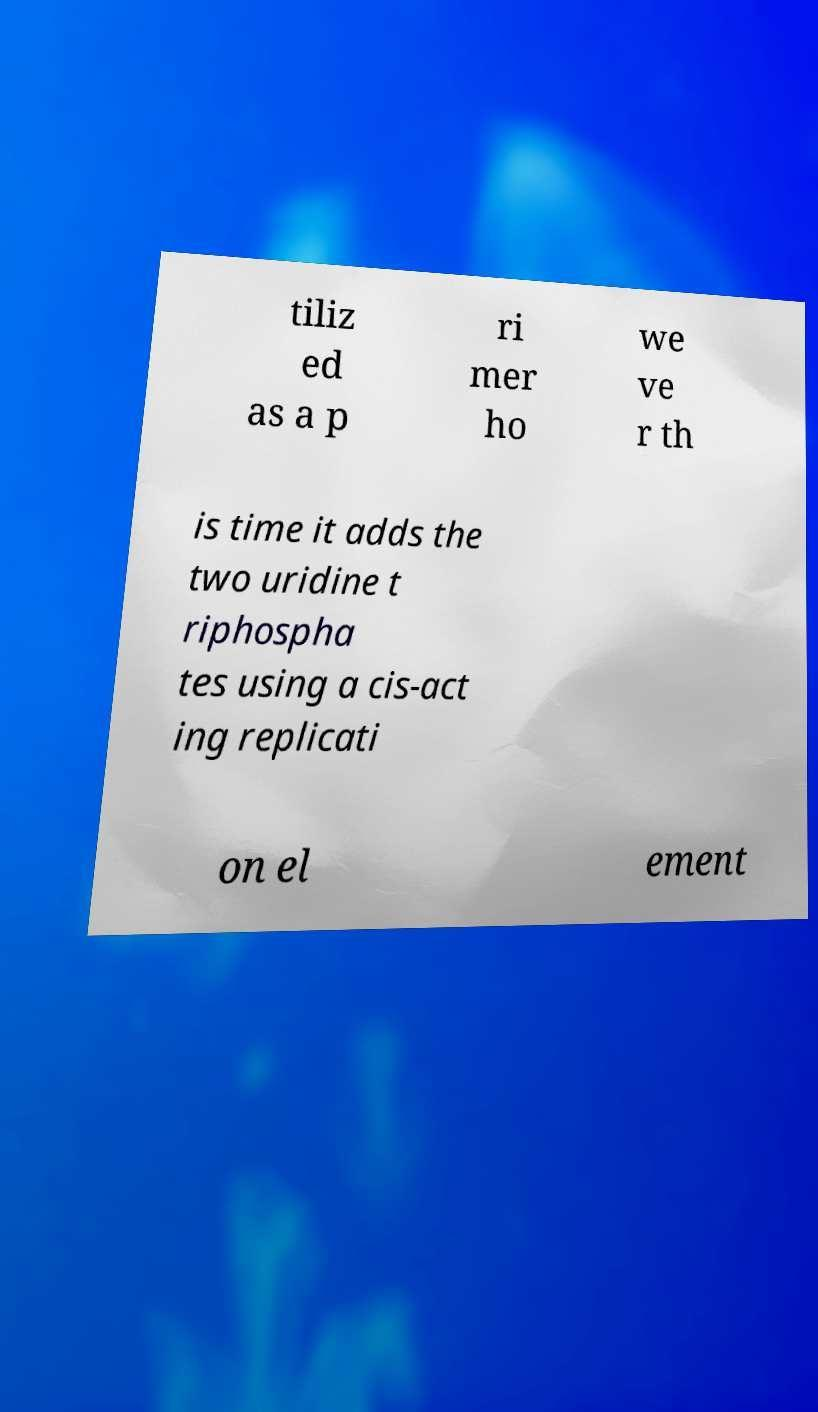For documentation purposes, I need the text within this image transcribed. Could you provide that? tiliz ed as a p ri mer ho we ve r th is time it adds the two uridine t riphospha tes using a cis-act ing replicati on el ement 